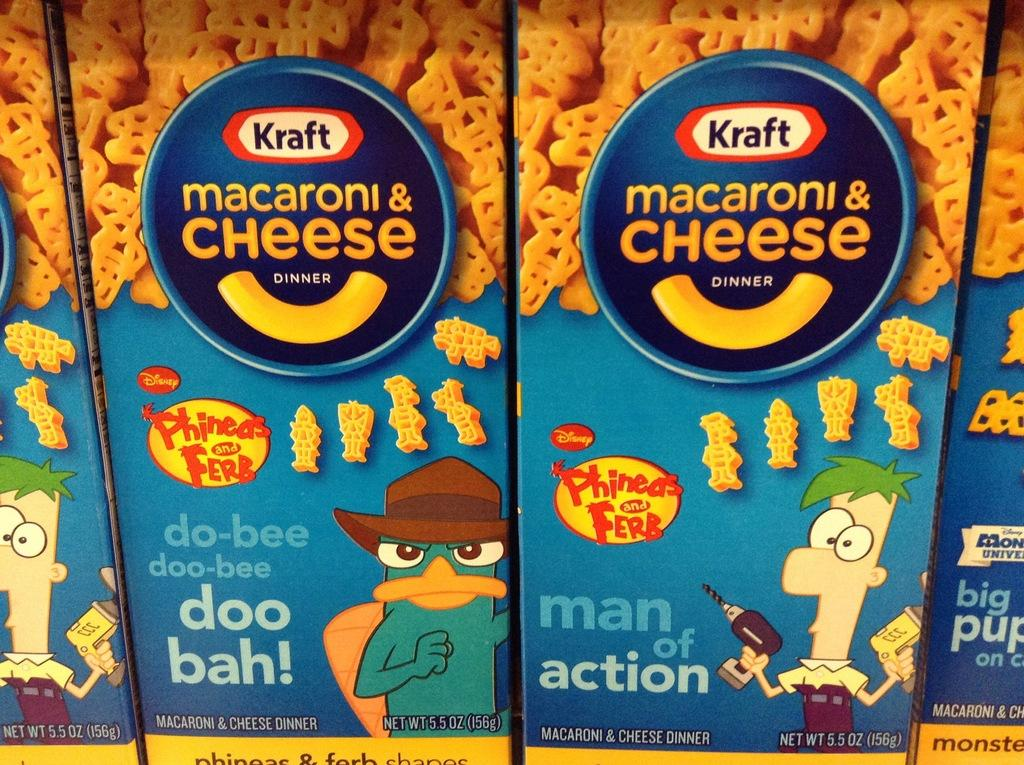What objects are in the foreground of the image? There are boxes in the foreground of the image. What can be seen on the boxes? There is text written on the boxes. What else is visible on the boxes? There are toys on the boxes. What type of cord is used to connect the machine to the boxes in the image? There is no machine or cord present in the image; it only features boxes with text and toys. 